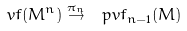<formula> <loc_0><loc_0><loc_500><loc_500>\ v f ( M ^ { n } ) \overset { \pi _ { n } } \to \ p v f _ { n - 1 } ( M )</formula> 